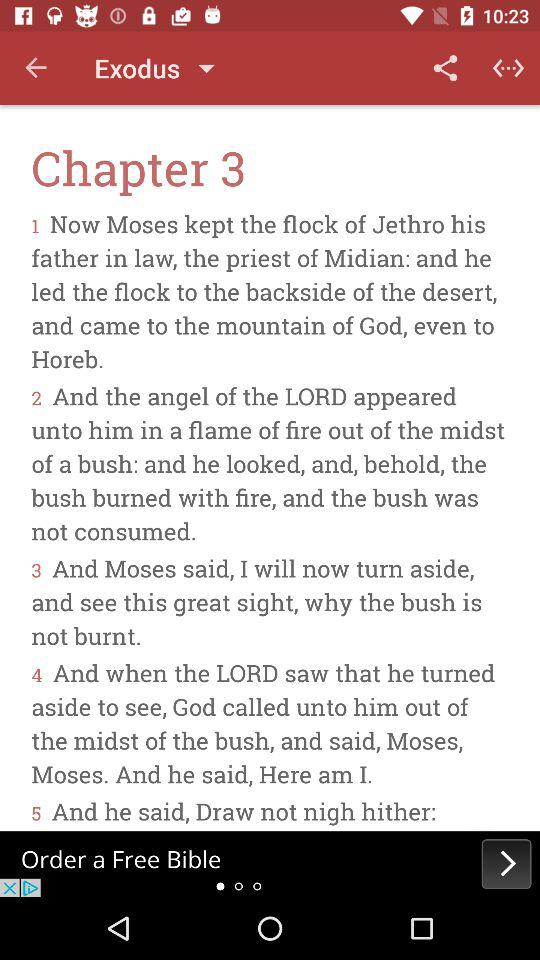What's the chapter number? The chapter number is 3. 